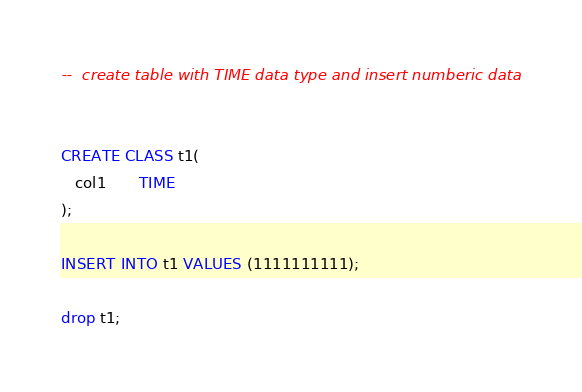<code> <loc_0><loc_0><loc_500><loc_500><_SQL_>--  create table with TIME data type and insert numberic data


CREATE CLASS t1(
   col1       TIME
);

INSERT INTO t1 VALUES (1111111111);

drop t1;</code> 